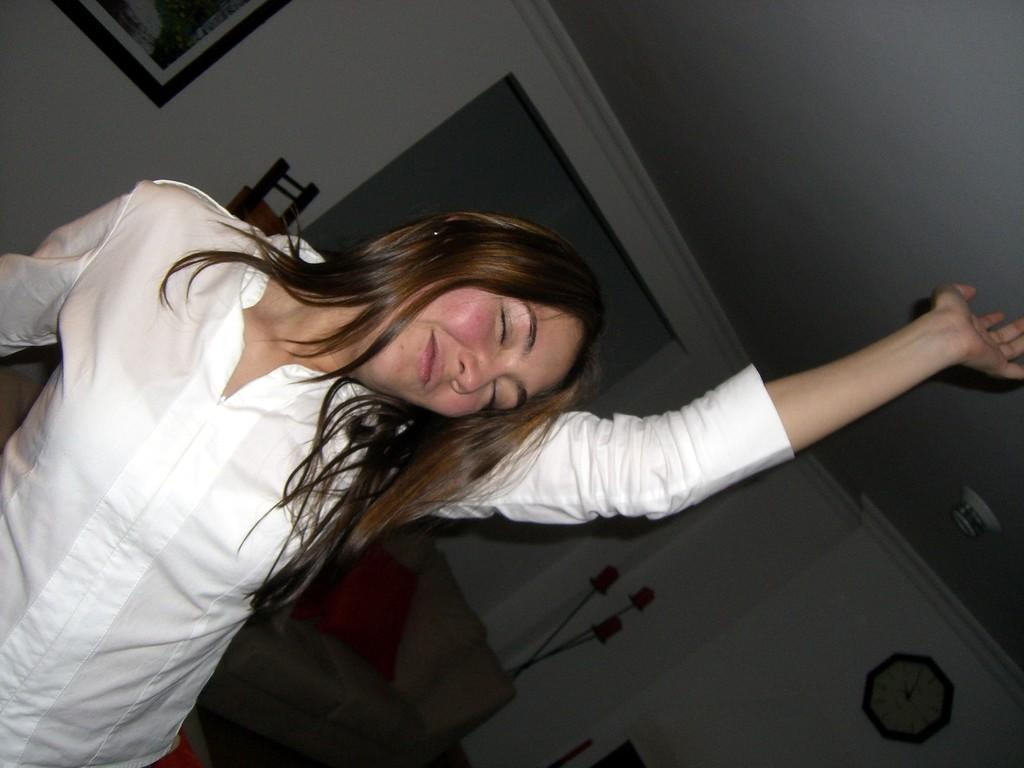Who is the main subject in the image? There is a woman in the image. What is the woman wearing? The woman is wearing a white dress. What is the woman doing in the image? The woman is dancing. What else can be seen in the background of the image? There are other objects in the background of the image. How many pages does the crowd in the image have? There is no crowd present in the image, and therefore no pages can be associated with it. 